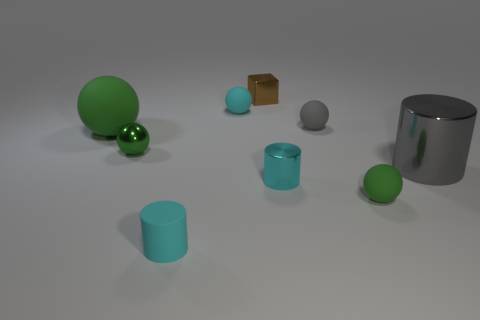What is the size of the other cylinder that is the same color as the tiny metal cylinder?
Provide a short and direct response. Small. There is a ball in front of the large gray object; is its color the same as the metal thing that is on the left side of the rubber cylinder?
Provide a succinct answer. Yes. What is the shape of the cyan thing that is the same material as the big cylinder?
Provide a short and direct response. Cylinder. There is a metal thing that is behind the cyan ball; does it have the same size as the green metallic ball?
Ensure brevity in your answer.  Yes. The tiny cyan metallic thing behind the green matte object that is in front of the tiny cyan metal thing is what shape?
Ensure brevity in your answer.  Cylinder. There is a green matte sphere that is on the left side of the small matte ball that is in front of the large metallic thing; how big is it?
Ensure brevity in your answer.  Large. There is a matte sphere in front of the big green ball; what color is it?
Provide a short and direct response. Green. What is the size of the cyan cylinder that is made of the same material as the small gray thing?
Your answer should be compact. Small. How many brown objects have the same shape as the big gray thing?
Offer a very short reply. 0. There is a gray sphere that is the same size as the rubber cylinder; what material is it?
Make the answer very short. Rubber. 